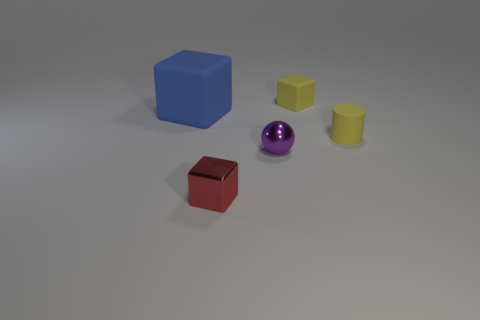Which objects in the image appear to have a shiny surface? The spherical object in the center has a reflective, shiny surface, noticeable through the highlights and the way it reflects the environment. 